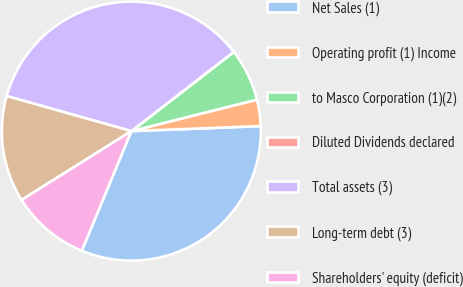<chart> <loc_0><loc_0><loc_500><loc_500><pie_chart><fcel>Net Sales (1)<fcel>Operating profit (1) Income<fcel>to Masco Corporation (1)(2)<fcel>Diluted Dividends declared<fcel>Total assets (3)<fcel>Long-term debt (3)<fcel>Shareholders' equity (deficit)<nl><fcel>31.87%<fcel>3.29%<fcel>6.57%<fcel>0.01%<fcel>35.15%<fcel>13.28%<fcel>9.84%<nl></chart> 